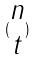<formula> <loc_0><loc_0><loc_500><loc_500>( \begin{matrix} n \\ t \end{matrix} )</formula> 